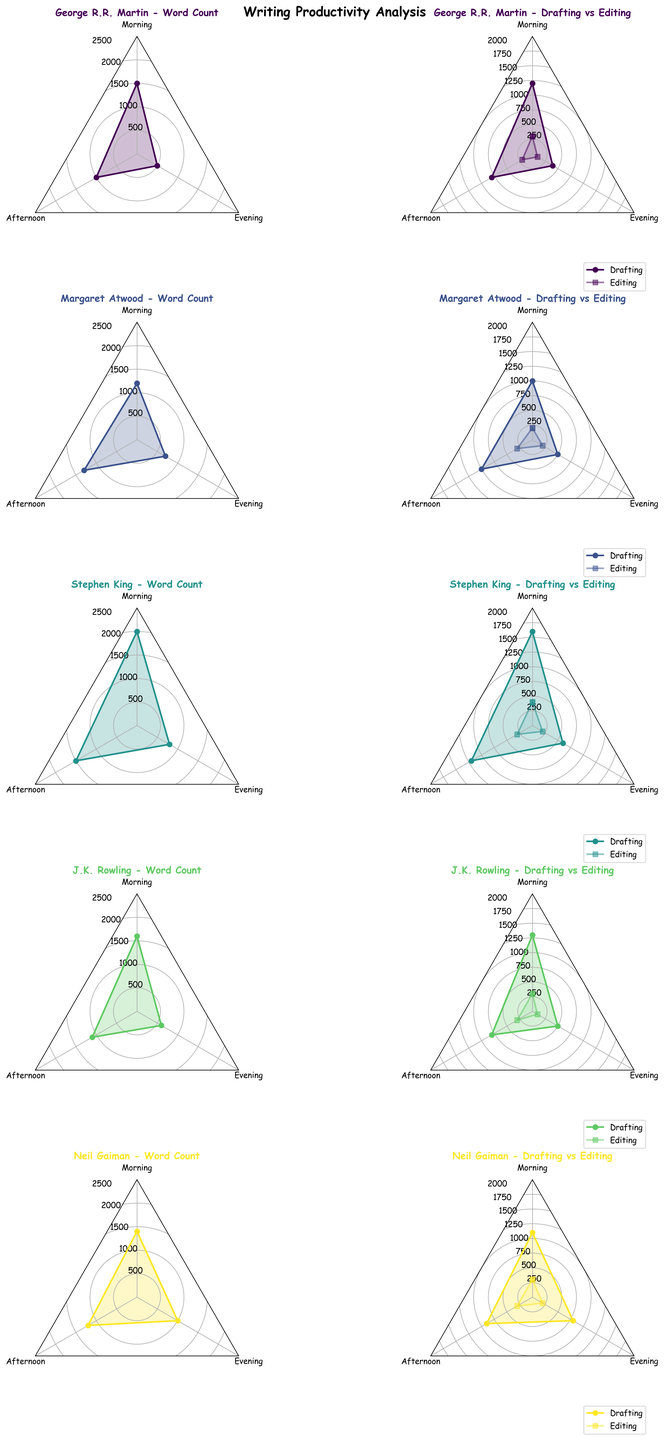Which author has the highest word count in the morning? By looking at the radar plot of the Word Count for each author, compare the morning values. Stephen King has the highest value with 2000 words.
Answer: Stephen King How do Margaret Atwood's evening word count compare to her afternoon word count? Compare the values on Margaret Atwood's Word Count radar plot for the Evening and Afternoon. The evening word count is 700, and the afternoon word count is 1300, so the evening is less.
Answer: Less Which time of day does Neil Gaiman spend more time drafting than editing? For Neil Gaiman's Drafting vs Editing radar plot, compare the drafting and editing values at each time of day. In the Morning (1100 vs. 300), Afternoon (900 vs. 300), and Evening (800 vs. 200), he spends more time drafting than editing for all times.
Answer: All Who has a higher afternoon drafting word count, George R.R. Martin or J.K. Rowling? Compare the Afternoon Drafting values in George R.R. Martin and J.K. Rowling's Drafting vs Editing radar plots. George R.R. Martin has 800, and J.K. Rowling has 800. They are equal.
Answer: Equal What is the total word count for J.K. Rowling across all times of day? For J.K. Rowling's Word Count radar plot, sum the values for Morning (1600), Afternoon (1100), and Evening (600). The total is 1600 + 1100 + 600 = 3300.
Answer: 3300 Explain the trend in Stephen King's drafting word count across the day. On Stephen King's Drafting vs Editing radar plot, the drafting values are 1600 in the Morning, 1200 in the Afternoon, and 600 in the Evening. The drafting word count decreases from morning to evening.
Answer: Decreases Which author's editing word count is the highest in the afternoon? Compare the Afternoon Editing values in each author's Drafting vs Editing radar plot. J.K. Rowling, Neil Gaiman, Margaret Atwood, and George R.R. Martin all have 300 words. Therefore, Margaret Atwood has the highest editing word count.
Answer: Margaret Atwood How does Neil Gaiman's evening drafting word count differ from his evening editing word count? For Neil Gaiman's Drafting vs Editing radar plot, subtract the evening editing word count (200) from the evening drafting word count (800). The difference is 800 - 200 = 600.
Answer: 600 What's the average morning word count for all authors? Sum the morning word counts for all authors and divide by the number of authors: (1500 + 1200 + 2000 + 1600 + 1400) = 7700; Divide by 5 (number of authors) = 7700/5 = 1540.
Answer: 1540 Which author has the most balanced productivity between drafting and editing in the afternoon? Look for the smallest difference between drafting and editing word counts for each author in the afternoon. Neil Gaiman has drafting 900 and editing 300; the difference is 600. The balanced productivity points towards George R.R. Martin. Finally, calculate the average point.
Answer: Neil Gaiman 